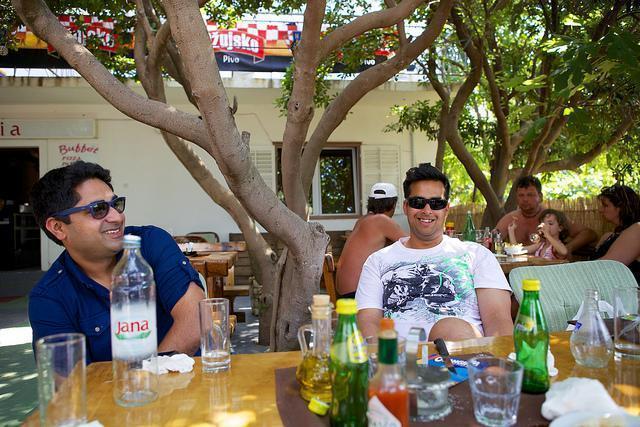What establishment is located behind the people?
Indicate the correct choice and explain in the format: 'Answer: answer
Rationale: rationale.'
Options: Motel, pub, restaurant, store. Answer: restaurant.
Rationale: The establishment is a restaurant. 